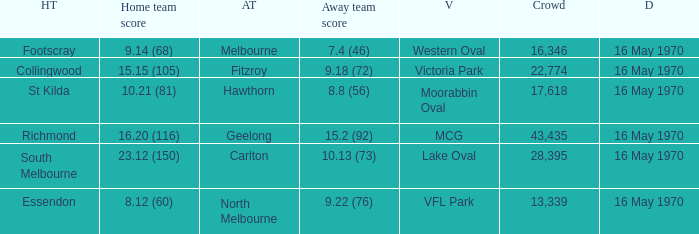What did the away team score when the home team was south melbourne? 10.13 (73). 